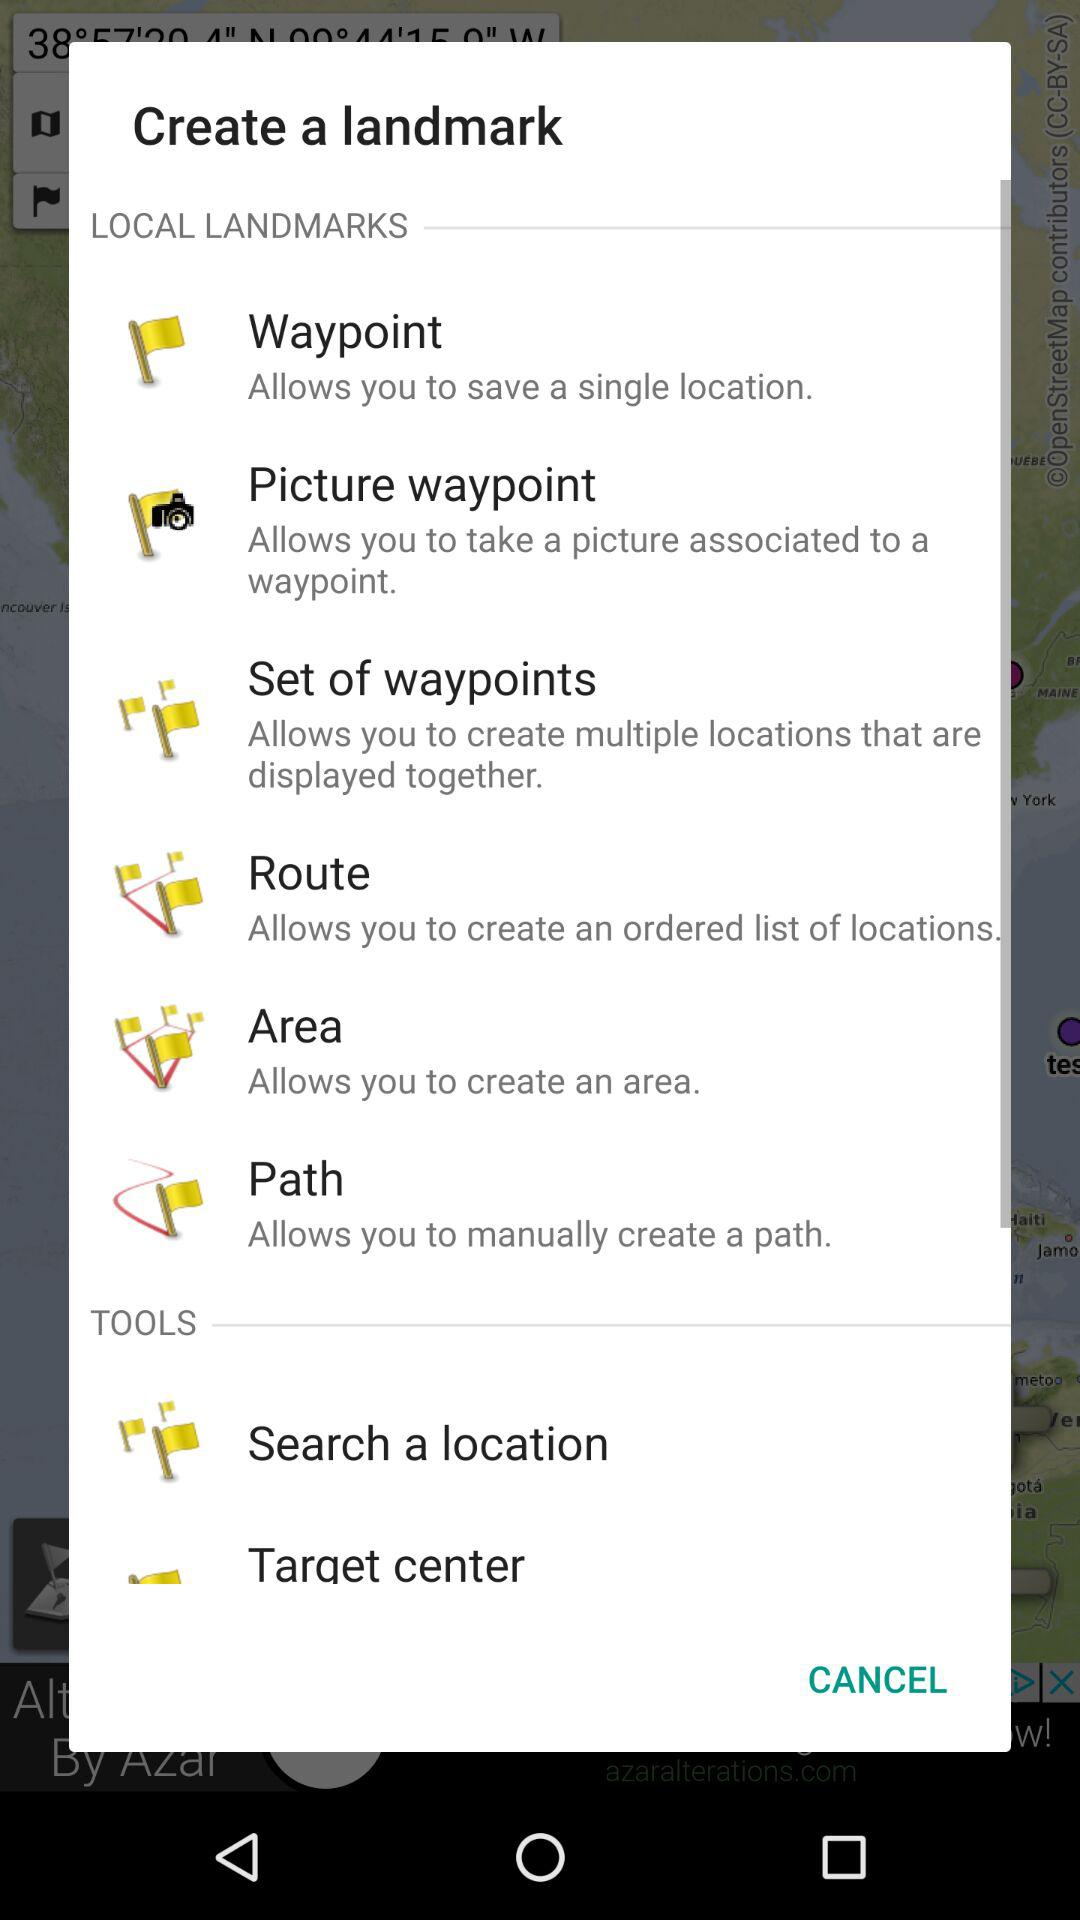What landmark setting allows one to create an ordered list of locations? The landmark setting is "Route". 